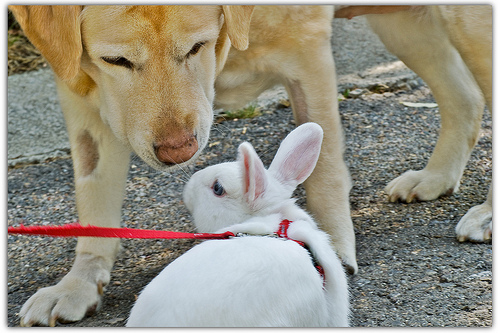<image>
Can you confirm if the dog is above the bunny? Yes. The dog is positioned above the bunny in the vertical space, higher up in the scene. 